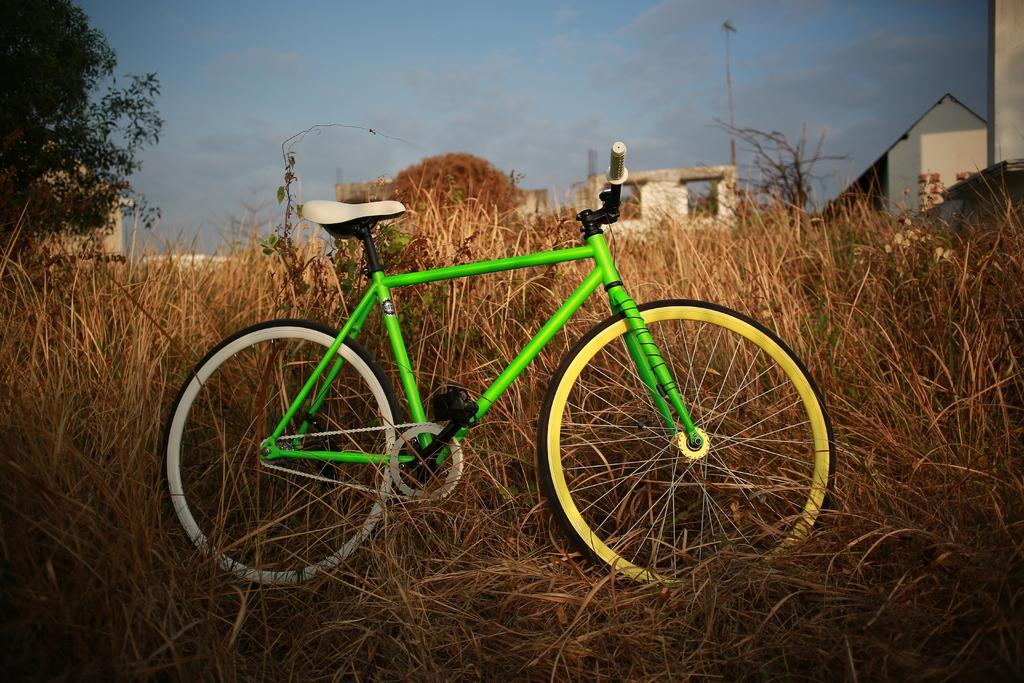What mode of transportation can be seen in the image? There is a cycle in the image. Where is the cycle located in relation to the other elements in the image? The cycle is parked beside dried grass. What type of structures can be seen in the background of the image? There are houses with roofs visible in the image. What natural element is present in the image? There is a tree in the image. What man-made object can be seen in the image besides the houses? There is a pole in the image. How would you describe the weather based on the image? The sky is visible in the image and appears cloudy. What arithmetic problem is being solved on the roof of the house in the image? There is no arithmetic problem visible in the image; it only shows a cycle, dried grass, houses, a tree, a pole, and a cloudy sky. 